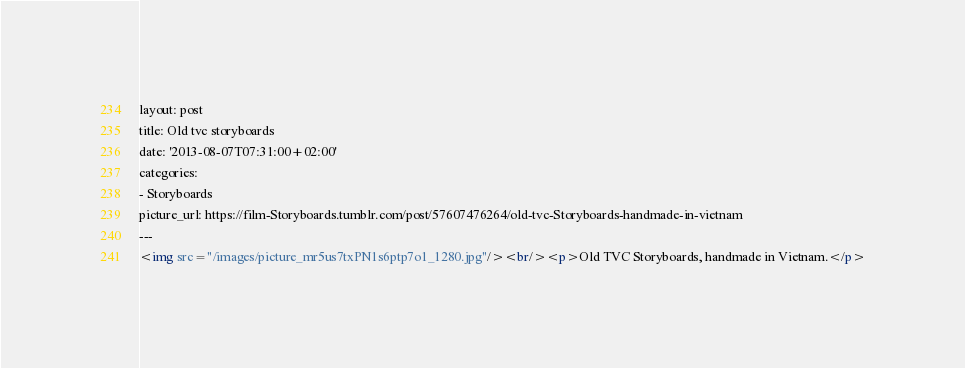Convert code to text. <code><loc_0><loc_0><loc_500><loc_500><_HTML_>layout: post
title: Old tvc storyboards
date: '2013-08-07T07:31:00+02:00'
categories:
- Storyboards
picture_url: https://film-Storyboards.tumblr.com/post/57607476264/old-tvc-Storyboards-handmade-in-vietnam
---
<img src="/images/picture_mr5us7txPN1s6ptp7o1_1280.jpg"/><br/><p>Old TVC Storyboards, handmade in Vietnam.</p>
</code> 